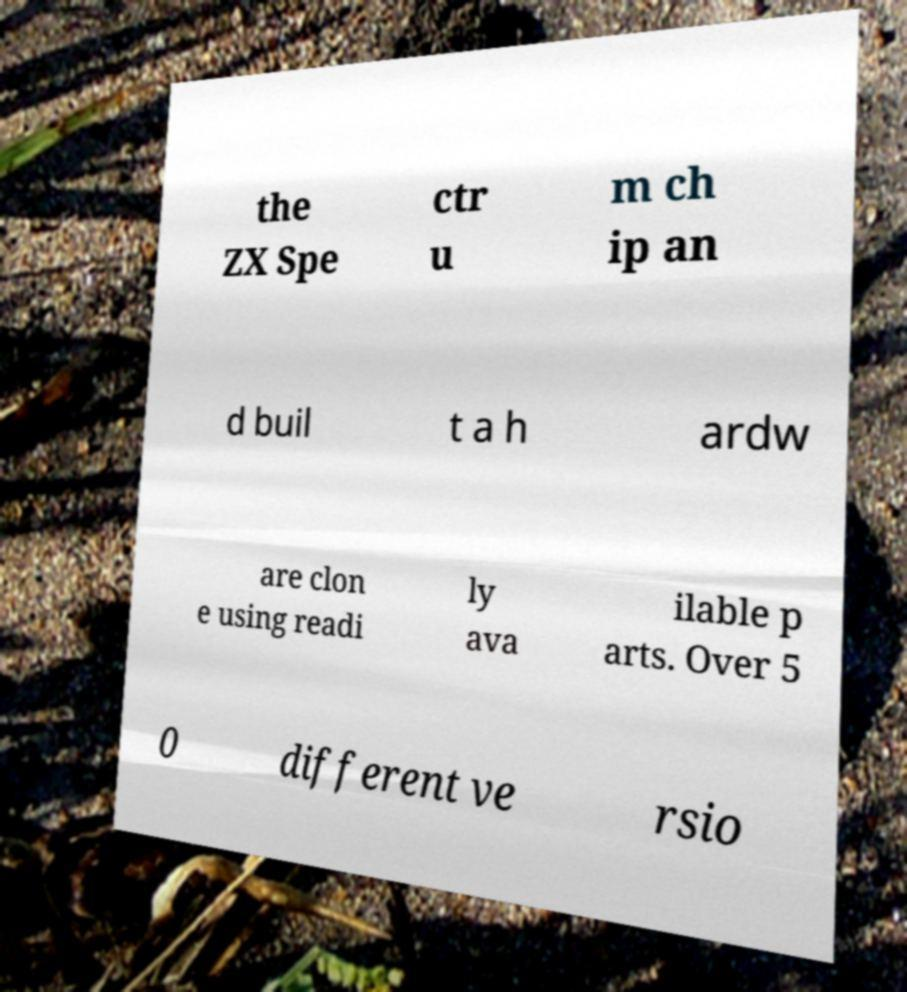Please read and relay the text visible in this image. What does it say? the ZX Spe ctr u m ch ip an d buil t a h ardw are clon e using readi ly ava ilable p arts. Over 5 0 different ve rsio 